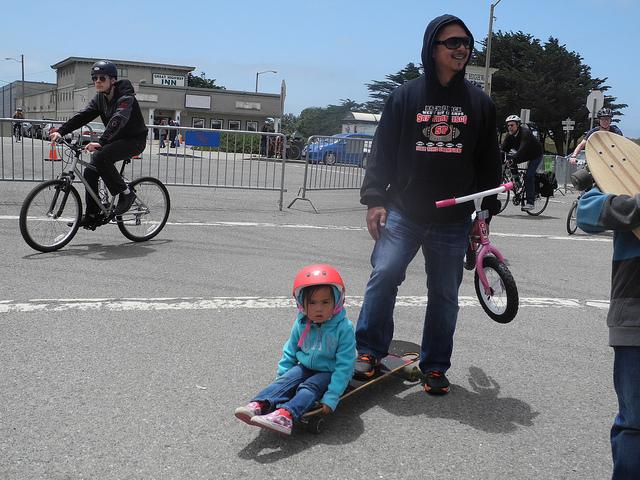Is it daytime?
Short answer required. Yes. What is the gentleman holding?
Give a very brief answer. Bike. Does the man ride the bike?
Answer briefly. No. 